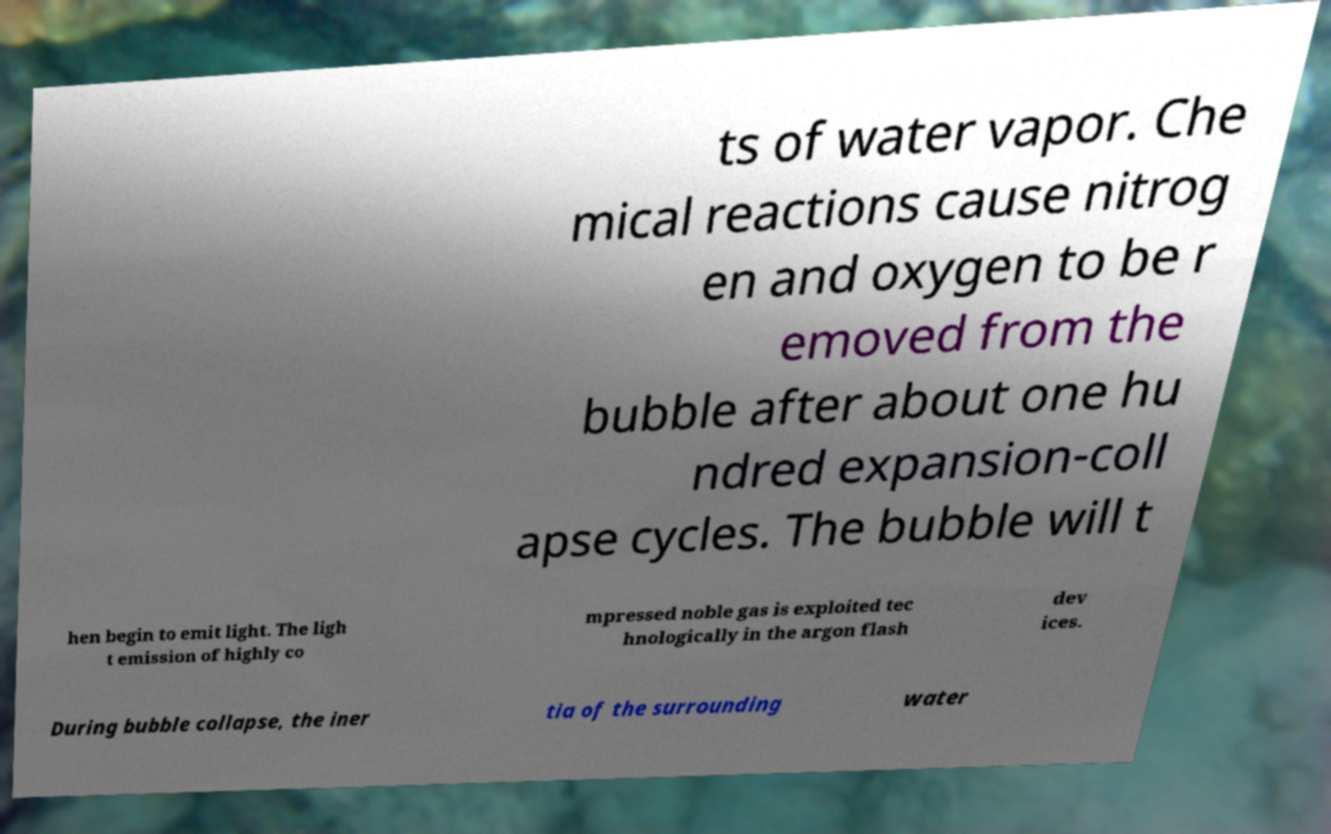Could you assist in decoding the text presented in this image and type it out clearly? ts of water vapor. Che mical reactions cause nitrog en and oxygen to be r emoved from the bubble after about one hu ndred expansion-coll apse cycles. The bubble will t hen begin to emit light. The ligh t emission of highly co mpressed noble gas is exploited tec hnologically in the argon flash dev ices. During bubble collapse, the iner tia of the surrounding water 